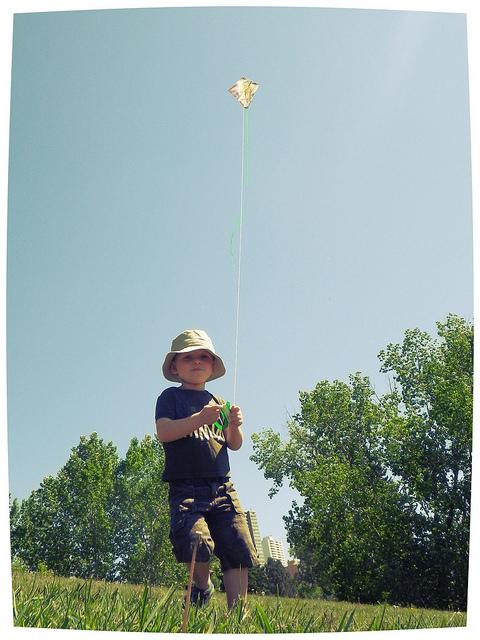What is the boy flying?
Write a very short answer. Kite. What is protecting the boy's eyes?
Be succinct. Hat. Is the boy alone?
Give a very brief answer. Yes. 